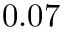<formula> <loc_0><loc_0><loc_500><loc_500>0 . 0 7</formula> 